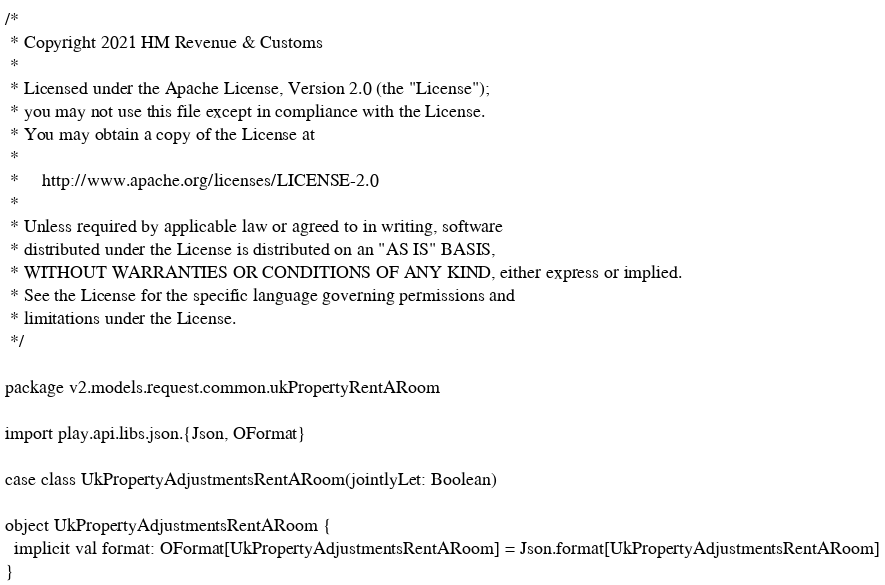<code> <loc_0><loc_0><loc_500><loc_500><_Scala_>/*
 * Copyright 2021 HM Revenue & Customs
 *
 * Licensed under the Apache License, Version 2.0 (the "License");
 * you may not use this file except in compliance with the License.
 * You may obtain a copy of the License at
 *
 *     http://www.apache.org/licenses/LICENSE-2.0
 *
 * Unless required by applicable law or agreed to in writing, software
 * distributed under the License is distributed on an "AS IS" BASIS,
 * WITHOUT WARRANTIES OR CONDITIONS OF ANY KIND, either express or implied.
 * See the License for the specific language governing permissions and
 * limitations under the License.
 */

package v2.models.request.common.ukPropertyRentARoom

import play.api.libs.json.{Json, OFormat}

case class UkPropertyAdjustmentsRentARoom(jointlyLet: Boolean)

object UkPropertyAdjustmentsRentARoom {
  implicit val format: OFormat[UkPropertyAdjustmentsRentARoom] = Json.format[UkPropertyAdjustmentsRentARoom]
}</code> 